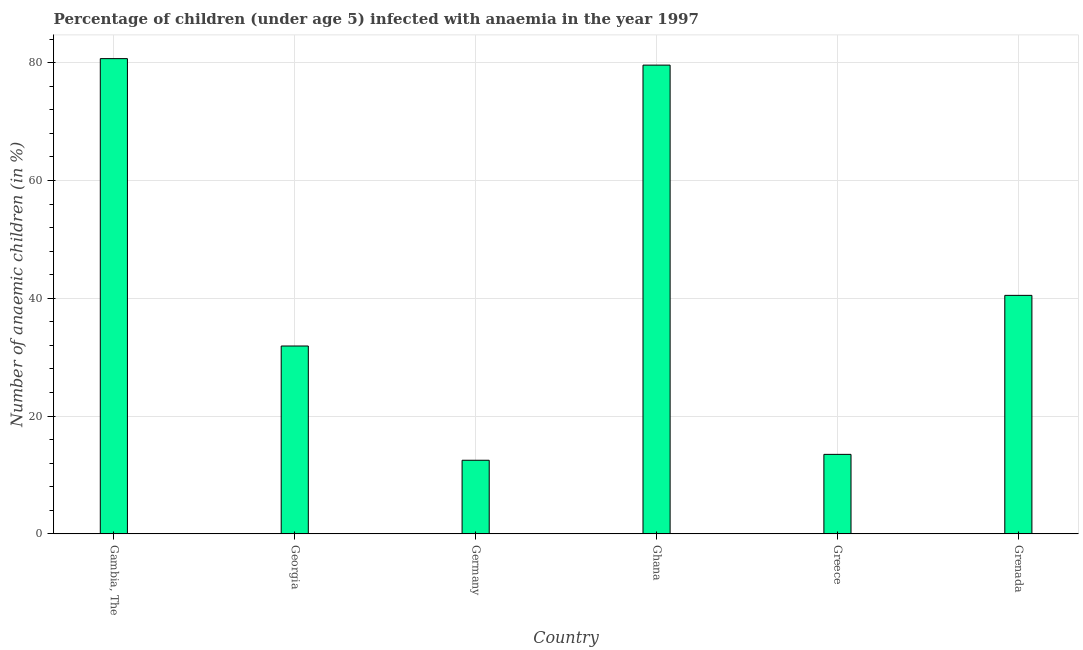Does the graph contain grids?
Offer a terse response. Yes. What is the title of the graph?
Provide a succinct answer. Percentage of children (under age 5) infected with anaemia in the year 1997. What is the label or title of the X-axis?
Provide a short and direct response. Country. What is the label or title of the Y-axis?
Keep it short and to the point. Number of anaemic children (in %). What is the number of anaemic children in Greece?
Your answer should be compact. 13.5. Across all countries, what is the maximum number of anaemic children?
Your answer should be very brief. 80.7. Across all countries, what is the minimum number of anaemic children?
Offer a terse response. 12.5. In which country was the number of anaemic children maximum?
Keep it short and to the point. Gambia, The. What is the sum of the number of anaemic children?
Provide a succinct answer. 258.7. What is the average number of anaemic children per country?
Make the answer very short. 43.12. What is the median number of anaemic children?
Provide a short and direct response. 36.2. In how many countries, is the number of anaemic children greater than 20 %?
Give a very brief answer. 4. What is the ratio of the number of anaemic children in Ghana to that in Greece?
Your answer should be very brief. 5.9. Is the number of anaemic children in Germany less than that in Greece?
Give a very brief answer. Yes. What is the difference between the highest and the second highest number of anaemic children?
Ensure brevity in your answer.  1.1. Is the sum of the number of anaemic children in Georgia and Germany greater than the maximum number of anaemic children across all countries?
Give a very brief answer. No. What is the difference between the highest and the lowest number of anaemic children?
Provide a short and direct response. 68.2. Are all the bars in the graph horizontal?
Make the answer very short. No. What is the difference between two consecutive major ticks on the Y-axis?
Ensure brevity in your answer.  20. What is the Number of anaemic children (in %) of Gambia, The?
Your response must be concise. 80.7. What is the Number of anaemic children (in %) of Georgia?
Offer a terse response. 31.9. What is the Number of anaemic children (in %) of Germany?
Offer a very short reply. 12.5. What is the Number of anaemic children (in %) of Ghana?
Give a very brief answer. 79.6. What is the Number of anaemic children (in %) in Grenada?
Keep it short and to the point. 40.5. What is the difference between the Number of anaemic children (in %) in Gambia, The and Georgia?
Give a very brief answer. 48.8. What is the difference between the Number of anaemic children (in %) in Gambia, The and Germany?
Give a very brief answer. 68.2. What is the difference between the Number of anaemic children (in %) in Gambia, The and Ghana?
Your answer should be very brief. 1.1. What is the difference between the Number of anaemic children (in %) in Gambia, The and Greece?
Offer a terse response. 67.2. What is the difference between the Number of anaemic children (in %) in Gambia, The and Grenada?
Offer a very short reply. 40.2. What is the difference between the Number of anaemic children (in %) in Georgia and Ghana?
Provide a short and direct response. -47.7. What is the difference between the Number of anaemic children (in %) in Georgia and Greece?
Give a very brief answer. 18.4. What is the difference between the Number of anaemic children (in %) in Germany and Ghana?
Offer a very short reply. -67.1. What is the difference between the Number of anaemic children (in %) in Germany and Grenada?
Your response must be concise. -28. What is the difference between the Number of anaemic children (in %) in Ghana and Greece?
Provide a succinct answer. 66.1. What is the difference between the Number of anaemic children (in %) in Ghana and Grenada?
Keep it short and to the point. 39.1. What is the difference between the Number of anaemic children (in %) in Greece and Grenada?
Provide a short and direct response. -27. What is the ratio of the Number of anaemic children (in %) in Gambia, The to that in Georgia?
Offer a very short reply. 2.53. What is the ratio of the Number of anaemic children (in %) in Gambia, The to that in Germany?
Offer a terse response. 6.46. What is the ratio of the Number of anaemic children (in %) in Gambia, The to that in Greece?
Provide a short and direct response. 5.98. What is the ratio of the Number of anaemic children (in %) in Gambia, The to that in Grenada?
Your answer should be very brief. 1.99. What is the ratio of the Number of anaemic children (in %) in Georgia to that in Germany?
Provide a short and direct response. 2.55. What is the ratio of the Number of anaemic children (in %) in Georgia to that in Ghana?
Your response must be concise. 0.4. What is the ratio of the Number of anaemic children (in %) in Georgia to that in Greece?
Provide a succinct answer. 2.36. What is the ratio of the Number of anaemic children (in %) in Georgia to that in Grenada?
Offer a very short reply. 0.79. What is the ratio of the Number of anaemic children (in %) in Germany to that in Ghana?
Give a very brief answer. 0.16. What is the ratio of the Number of anaemic children (in %) in Germany to that in Greece?
Provide a succinct answer. 0.93. What is the ratio of the Number of anaemic children (in %) in Germany to that in Grenada?
Offer a very short reply. 0.31. What is the ratio of the Number of anaemic children (in %) in Ghana to that in Greece?
Give a very brief answer. 5.9. What is the ratio of the Number of anaemic children (in %) in Ghana to that in Grenada?
Your answer should be very brief. 1.97. What is the ratio of the Number of anaemic children (in %) in Greece to that in Grenada?
Your answer should be compact. 0.33. 